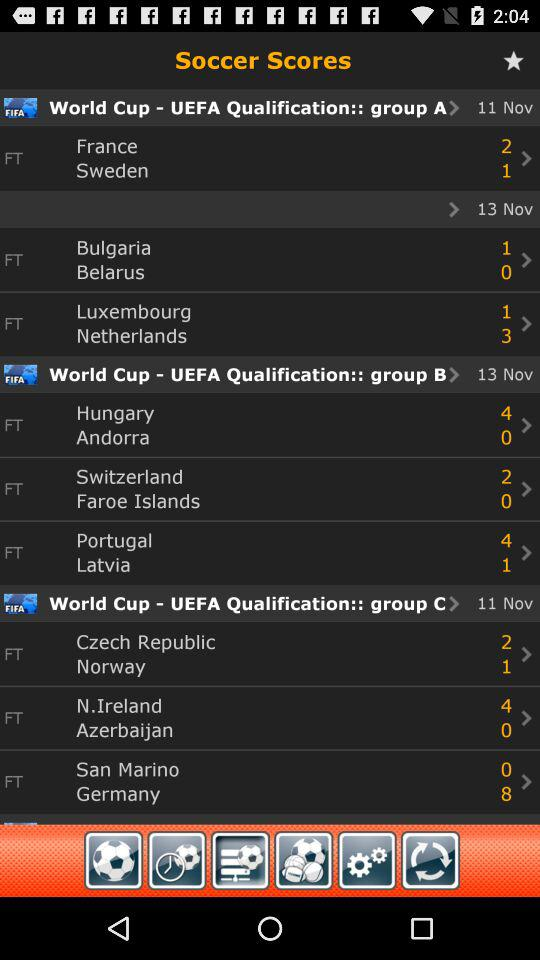What is the score of "Bulgaria" and "Belarus"? The score of "Bulgaria" is 1 and the score of "Belarus" is 0. 